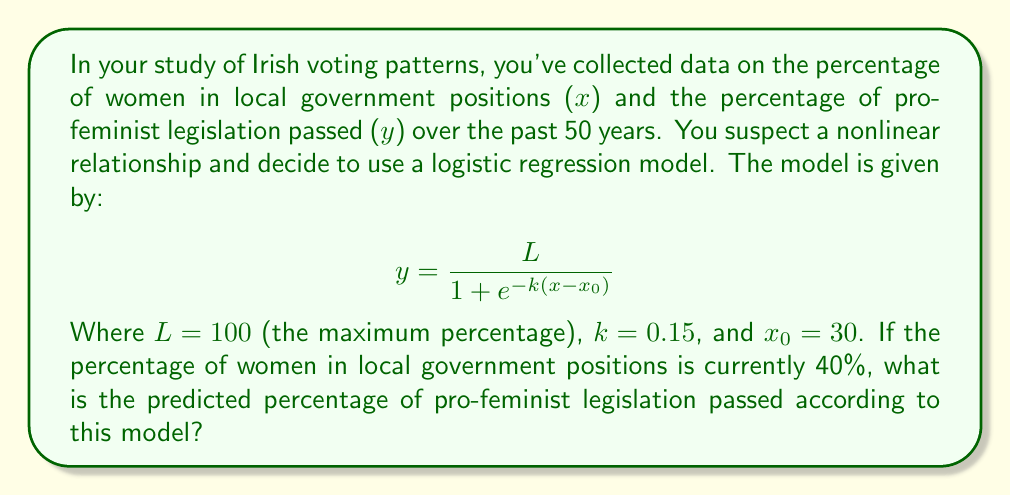Can you solve this math problem? To solve this problem, we'll follow these steps:

1. Identify the given parameters:
   L = 100 (maximum percentage)
   k = 0.15 (steepness of the curve)
   $x_0$ = 30 (midpoint of the sigmoid)
   x = 40 (current percentage of women in local government)

2. Substitute these values into the logistic regression equation:

   $$ y = \frac{100}{1 + e^{-0.15(40-30)}} $$

3. Simplify the expression inside the exponential:
   
   $$ y = \frac{100}{1 + e^{-0.15(10)}} = \frac{100}{1 + e^{-1.5}} $$

4. Calculate $e^{-1.5}$:
   
   $e^{-1.5} \approx 0.2231$

5. Substitute this value back into the equation:

   $$ y = \frac{100}{1 + 0.2231} = \frac{100}{1.2231} $$

6. Perform the division:

   $y \approx 81.76$

7. Round to two decimal places for the final answer.
Answer: 81.76% 